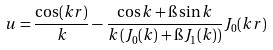Convert formula to latex. <formula><loc_0><loc_0><loc_500><loc_500>u = \frac { \cos ( k r ) } { k } - \frac { \cos k + \i \sin k } { k \left ( J _ { 0 } ( k ) + \i J _ { 1 } ( k ) \right ) } J _ { 0 } ( k r )</formula> 